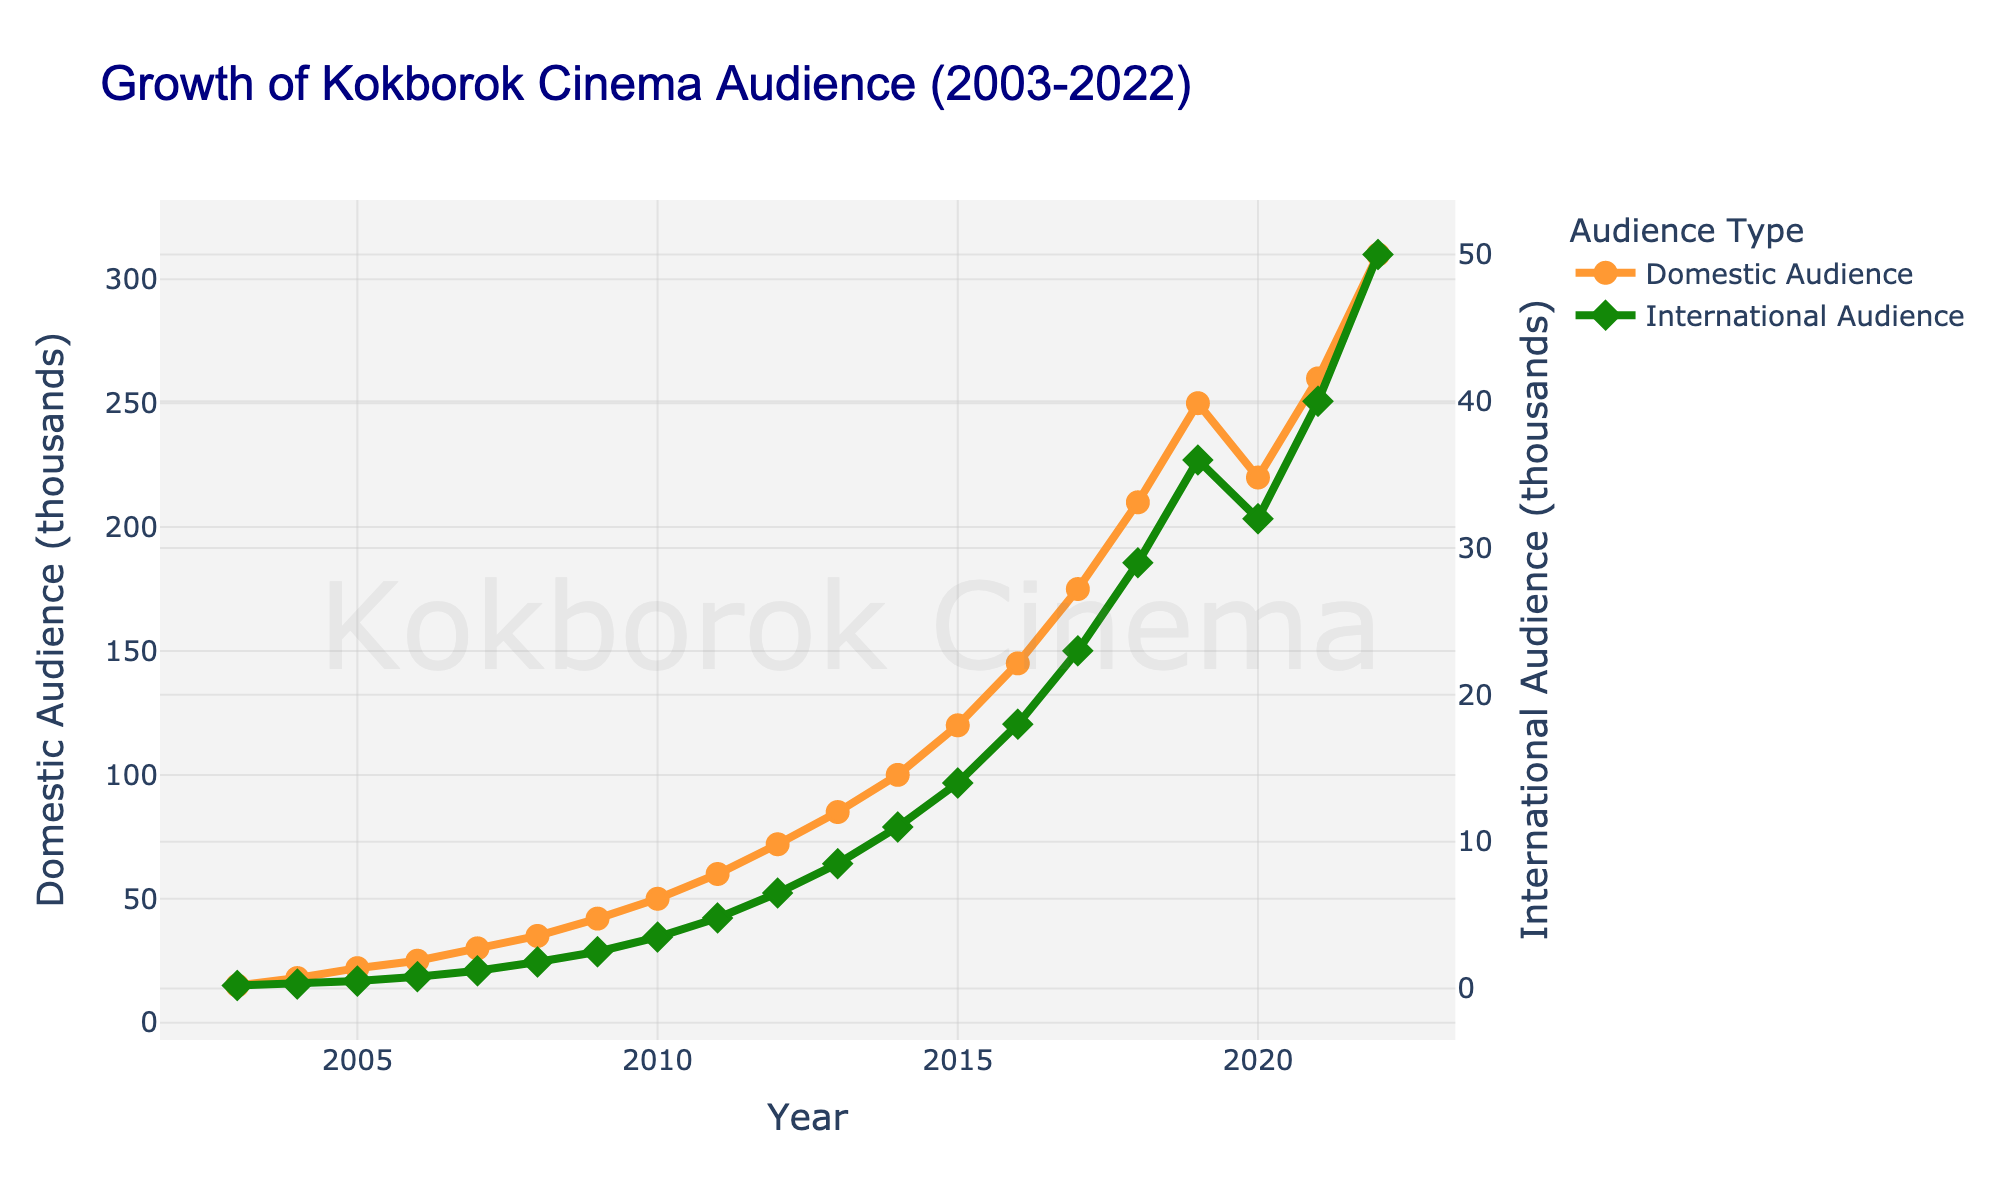what year saw the highest domestic audience? The year with the highest domestic audience can be found by looking at the peak point of the orange line. That occurs in 2022.
Answer: 2022 what is the difference in domestic audience between 2021 and 2022? To calculate the difference, subtract the 2021 value (260 thousands) from the 2022 value (310 thousands): 310 - 260 = 50.
Answer: 50 thousand how much did the international audience grow from 2003 to 2022? The international audience in 2003 was 0.2 thousand, and it grew to 50 thousand in 2022. The increase is calculated as 50 - 0.2 = 49.8.
Answer: 49.8 thousand during which period was the growth in domestic audience the fastest? The fastest growth can be observed by the steepest slope in the orange line. The period from 2018 to 2019 shows a rapid increase from 210 thousand to 250 thousand.
Answer: 2018 to 2019 what was the approximate average international audience from 2010 to 2020? To find the average, sum the international audience values for the years 2010 to 2020 and divide by the number of years: (3.5 + 4.8 + 6.5 + 8.5 + 11 + 14 + 18 + 23 + 29 + 36 + 32) / 11 ≈ 16.18 thousand.
Answer: 16.18 thousand is there any year when the international audience decreased compared to the previous year? Examining the green line for any downward trends shows that in 2020 the international audience decreased from 36 thousand (2019) to 32 thousand.
Answer: 2020 how do the trends in domestic and international audiences compare visually? Visually, the domestic audience displays a more consistent upward trend with some minor fluctuations, while the international audience has more noticeable fluctuations but generally follows an upward trend. Both lines show overall growth across two decades.
Answer: consistent vs fluctuating growth which year marks the first time the domestic audience surpasses 100 thousand? The orange line surpasses the 100 thousand mark in 2014 when the domestic audience reaches 100 thousand.
Answer: 2014 what is the ratio of international to domestic audiences in 2015? The domestic audience in 2015 is 120 thousand, and the international audience is 14 thousand. The ratio is calculated as 14 / 120 ≈ 0.1167.
Answer: 0.1167 how does the audience growth trend for Kokborok cinema in the last decade compare to the first decade? Visually comparing the trends, the first decade (2003-2012) has relatively steadier growth for both domestic and international audiences, while the last decade (2013-2022) shows more rapid increases in both metrics, especially after 2015.
Answer: more rapid in the last decade 